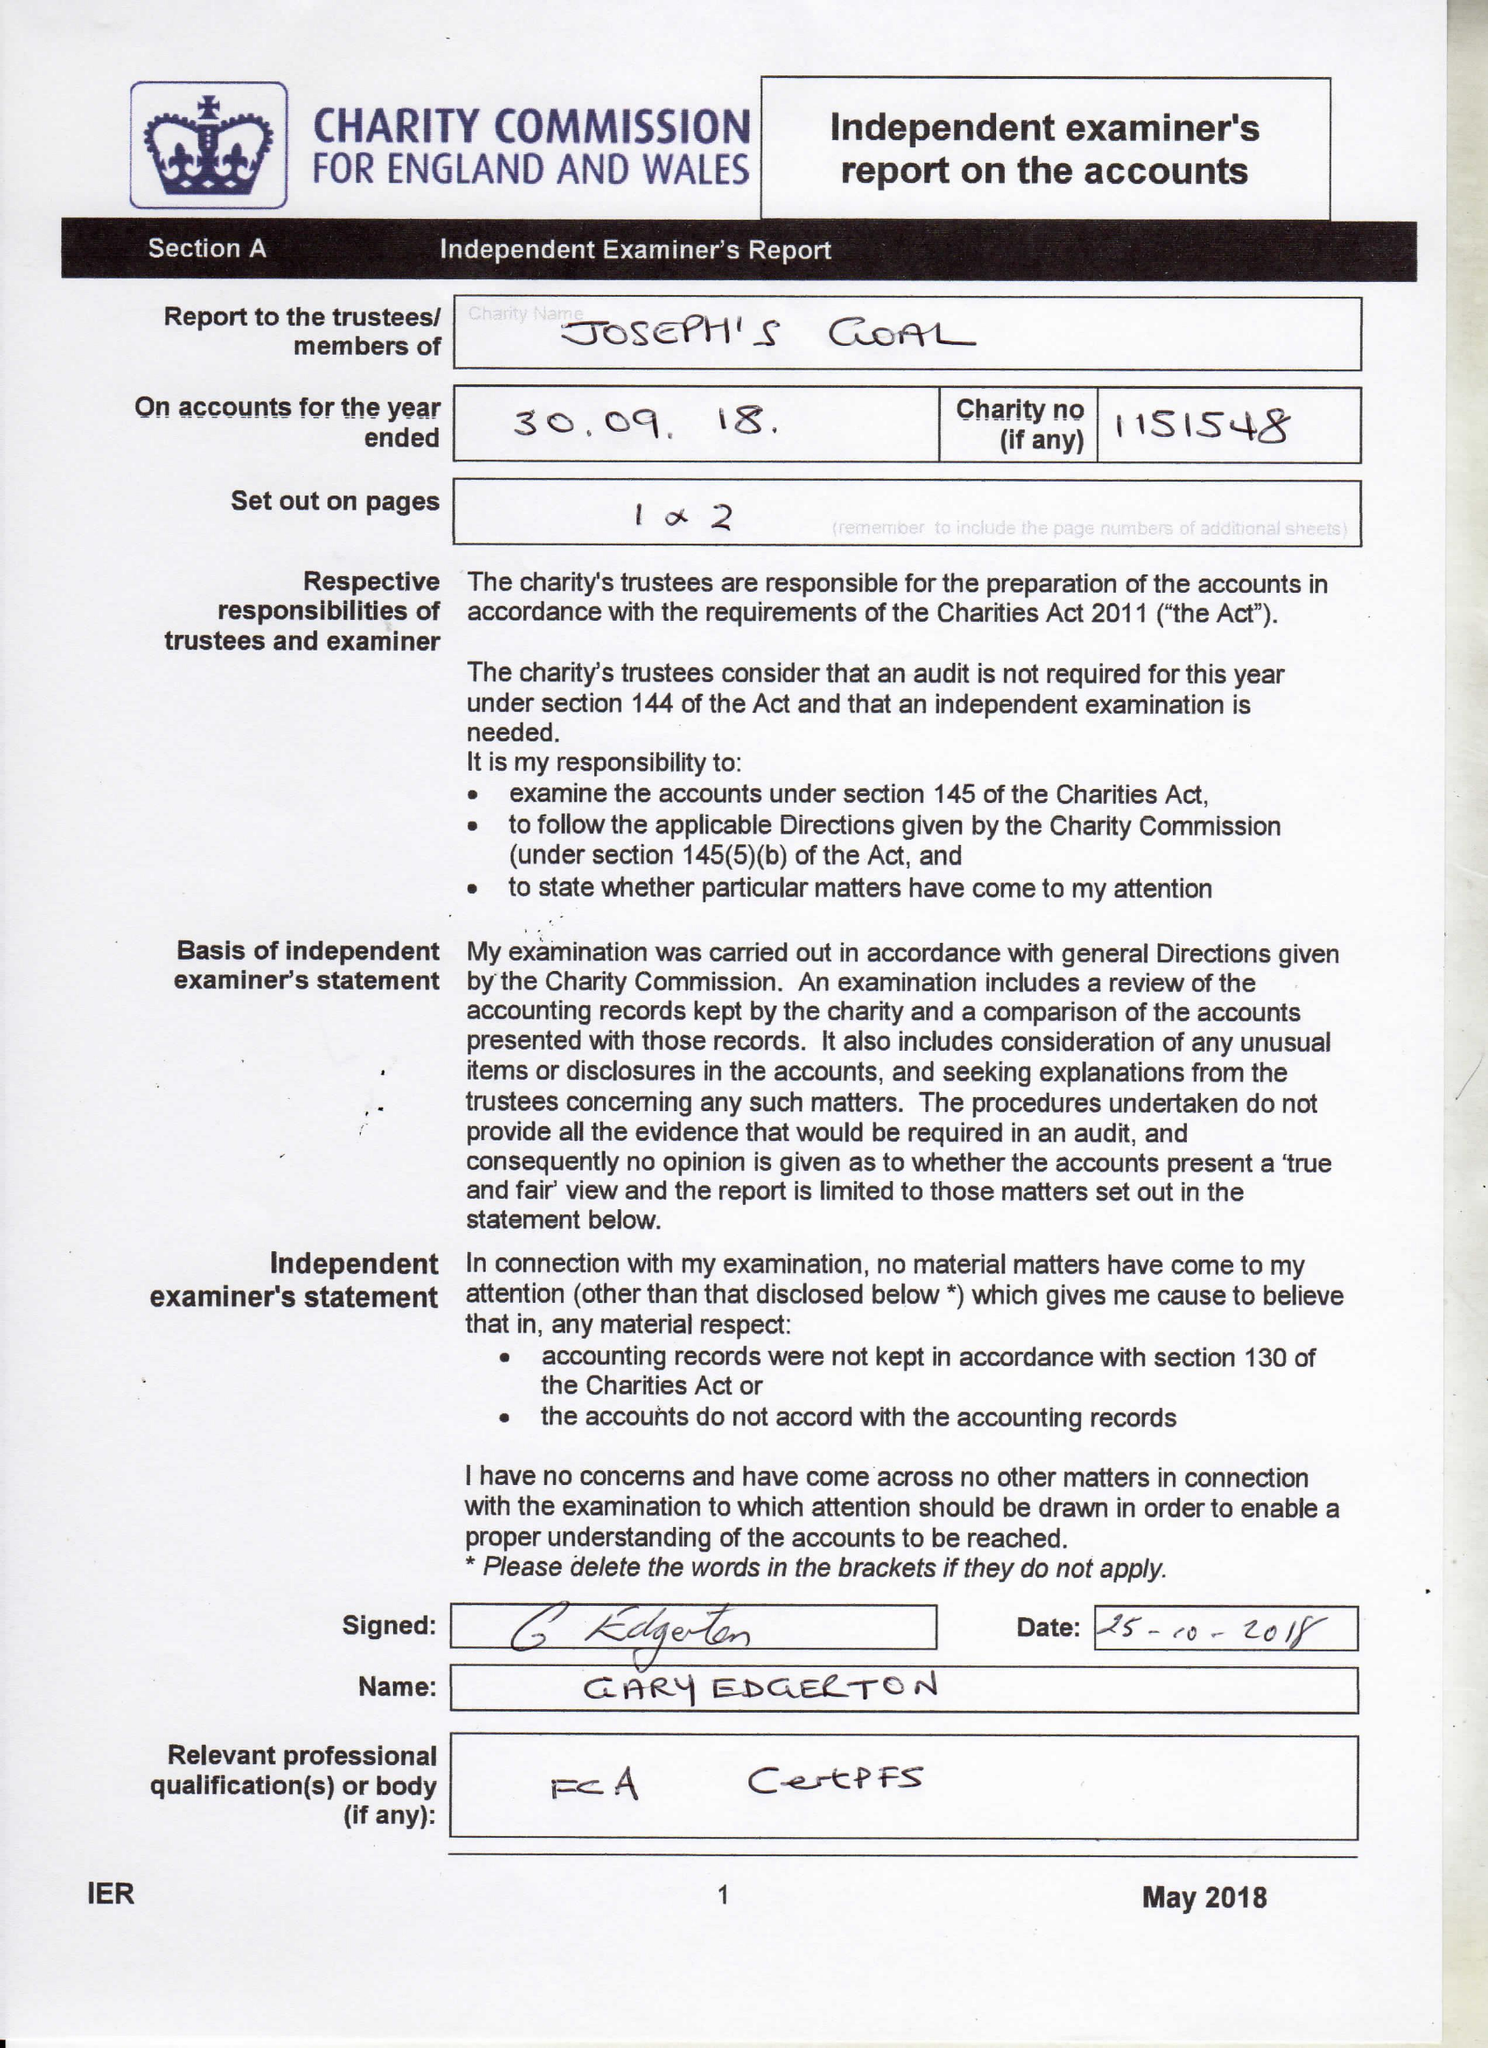What is the value for the charity_number?
Answer the question using a single word or phrase. 1151548 